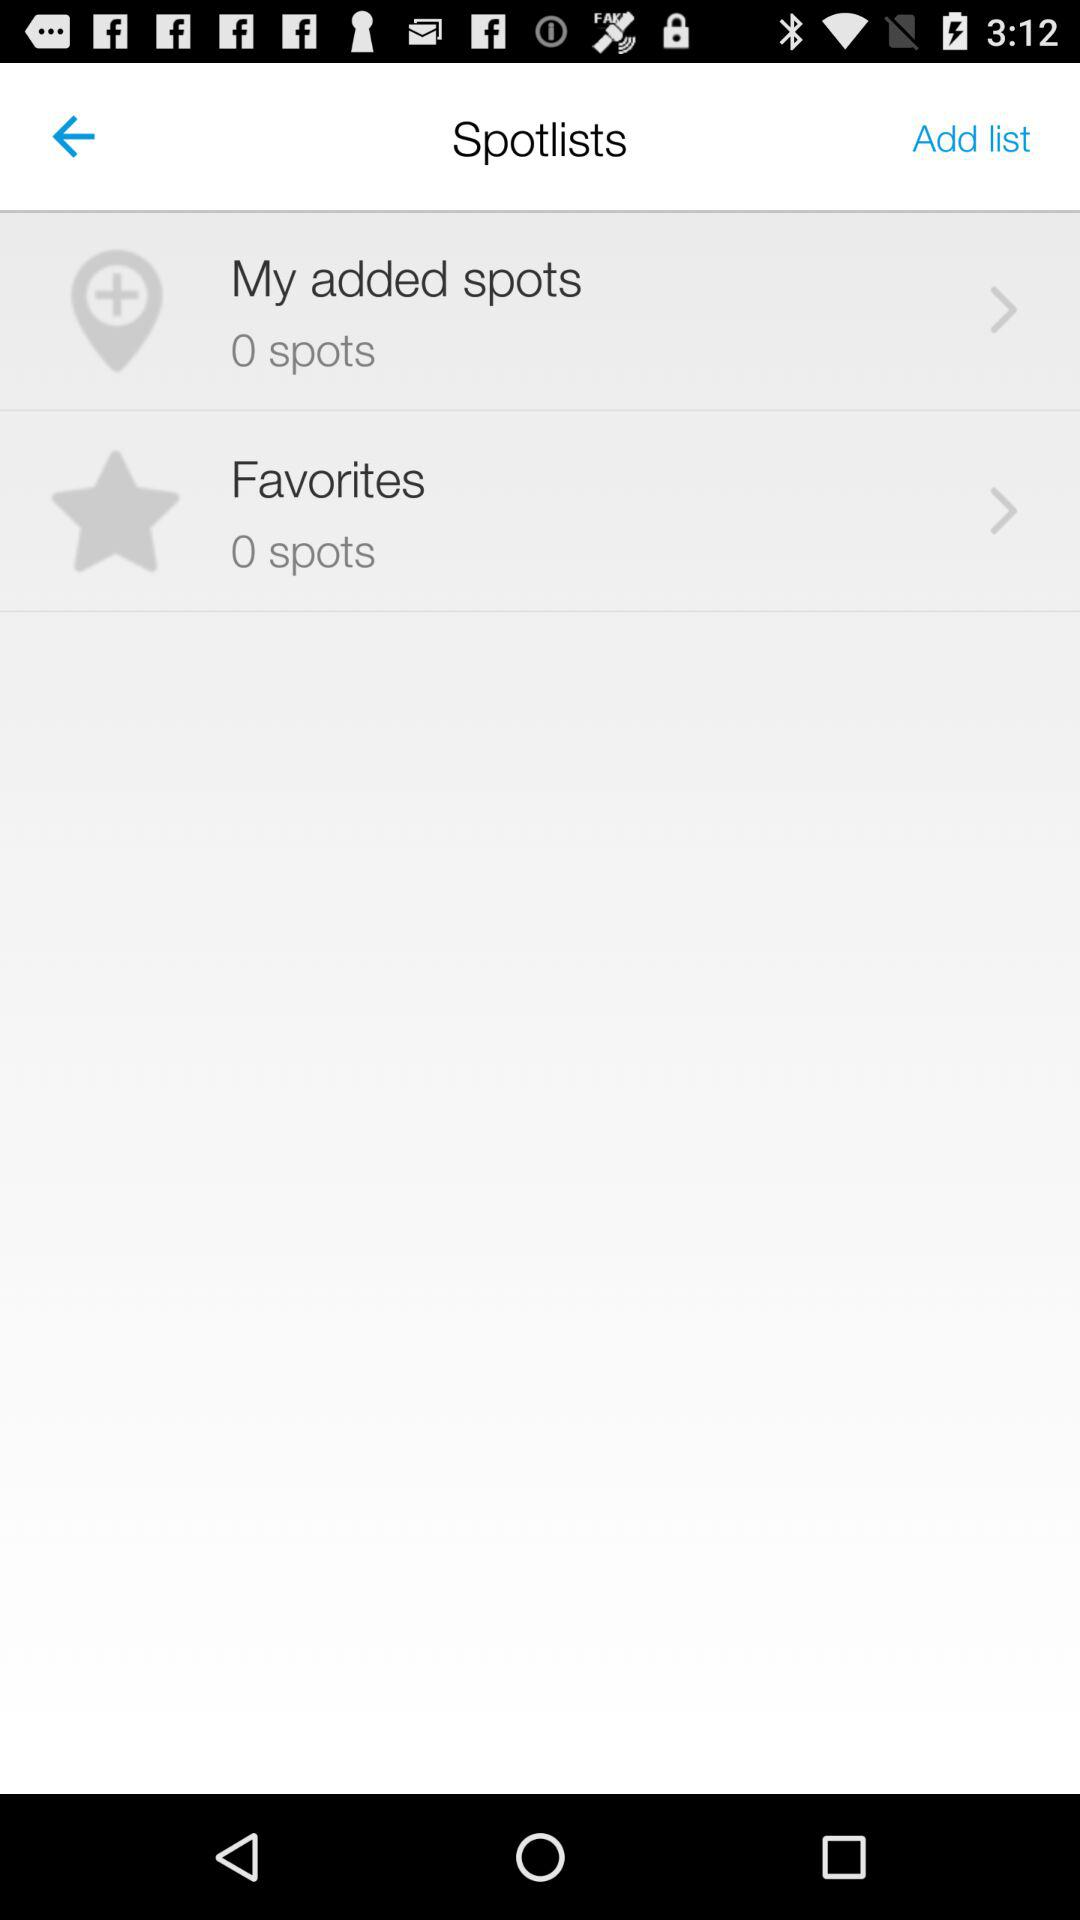How many spots are in "My added spots"? There are 0 spots. 